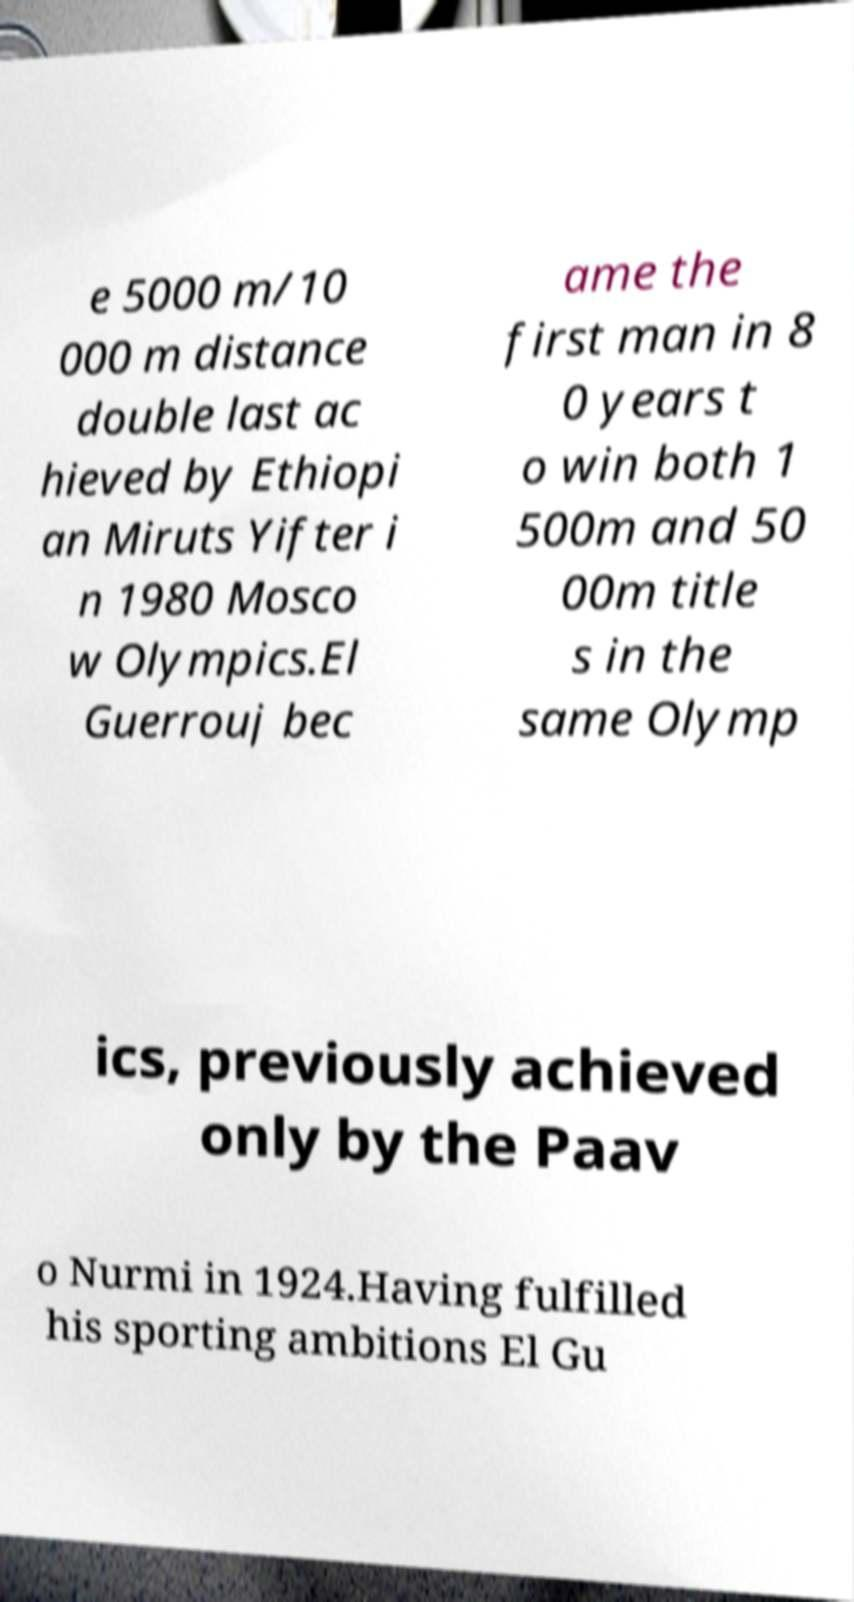Please read and relay the text visible in this image. What does it say? e 5000 m/10 000 m distance double last ac hieved by Ethiopi an Miruts Yifter i n 1980 Mosco w Olympics.El Guerrouj bec ame the first man in 8 0 years t o win both 1 500m and 50 00m title s in the same Olymp ics, previously achieved only by the Paav o Nurmi in 1924.Having fulfilled his sporting ambitions El Gu 